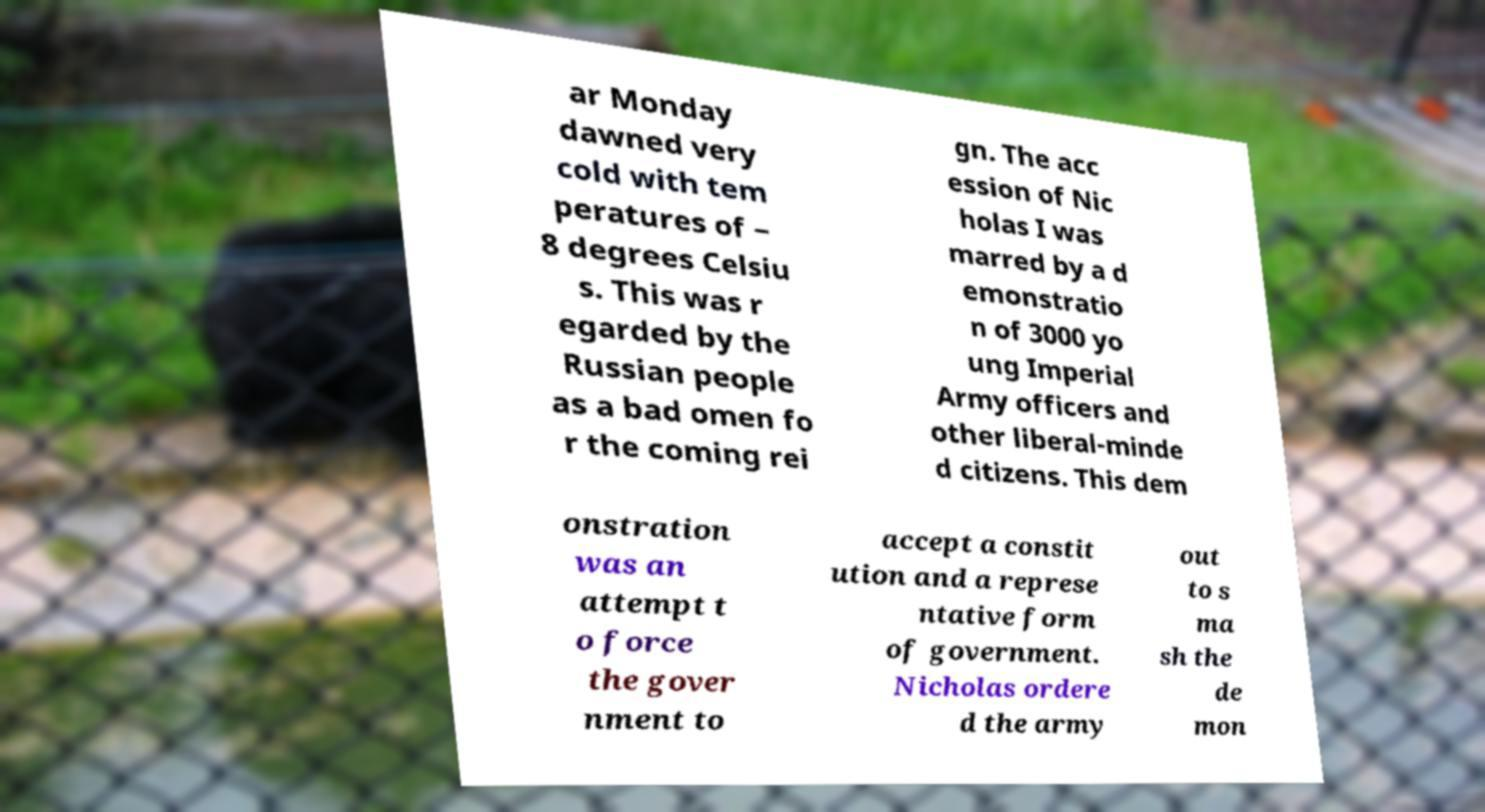Can you accurately transcribe the text from the provided image for me? ar Monday dawned very cold with tem peratures of − 8 degrees Celsiu s. This was r egarded by the Russian people as a bad omen fo r the coming rei gn. The acc ession of Nic holas I was marred by a d emonstratio n of 3000 yo ung Imperial Army officers and other liberal-minde d citizens. This dem onstration was an attempt t o force the gover nment to accept a constit ution and a represe ntative form of government. Nicholas ordere d the army out to s ma sh the de mon 